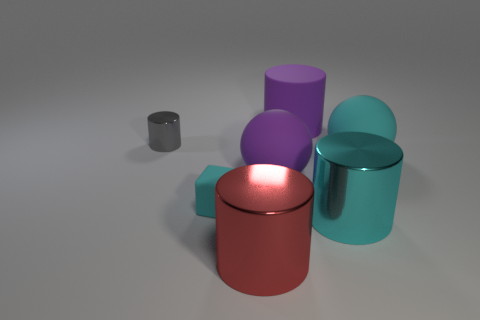What size is the purple object behind the large cyan matte ball?
Your answer should be compact. Large. What number of other objects are there of the same material as the gray object?
Your answer should be very brief. 2. Is there a big matte sphere that is right of the metallic thing that is to the right of the red metal thing?
Keep it short and to the point. Yes. Is there anything else that has the same shape as the small rubber thing?
Keep it short and to the point. No. There is a big matte thing that is the same shape as the tiny gray thing; what is its color?
Keep it short and to the point. Purple. What size is the matte cylinder?
Keep it short and to the point. Large. Are there fewer cyan shiny objects that are to the right of the tiny metallic cylinder than purple rubber things?
Provide a short and direct response. Yes. Is the cyan block made of the same material as the big object that is to the right of the big cyan cylinder?
Your answer should be compact. Yes. Are there any balls left of the big purple thing behind the cyan matte object that is behind the small cyan cube?
Your response must be concise. Yes. There is a big cylinder that is made of the same material as the small cyan block; what is its color?
Give a very brief answer. Purple. 